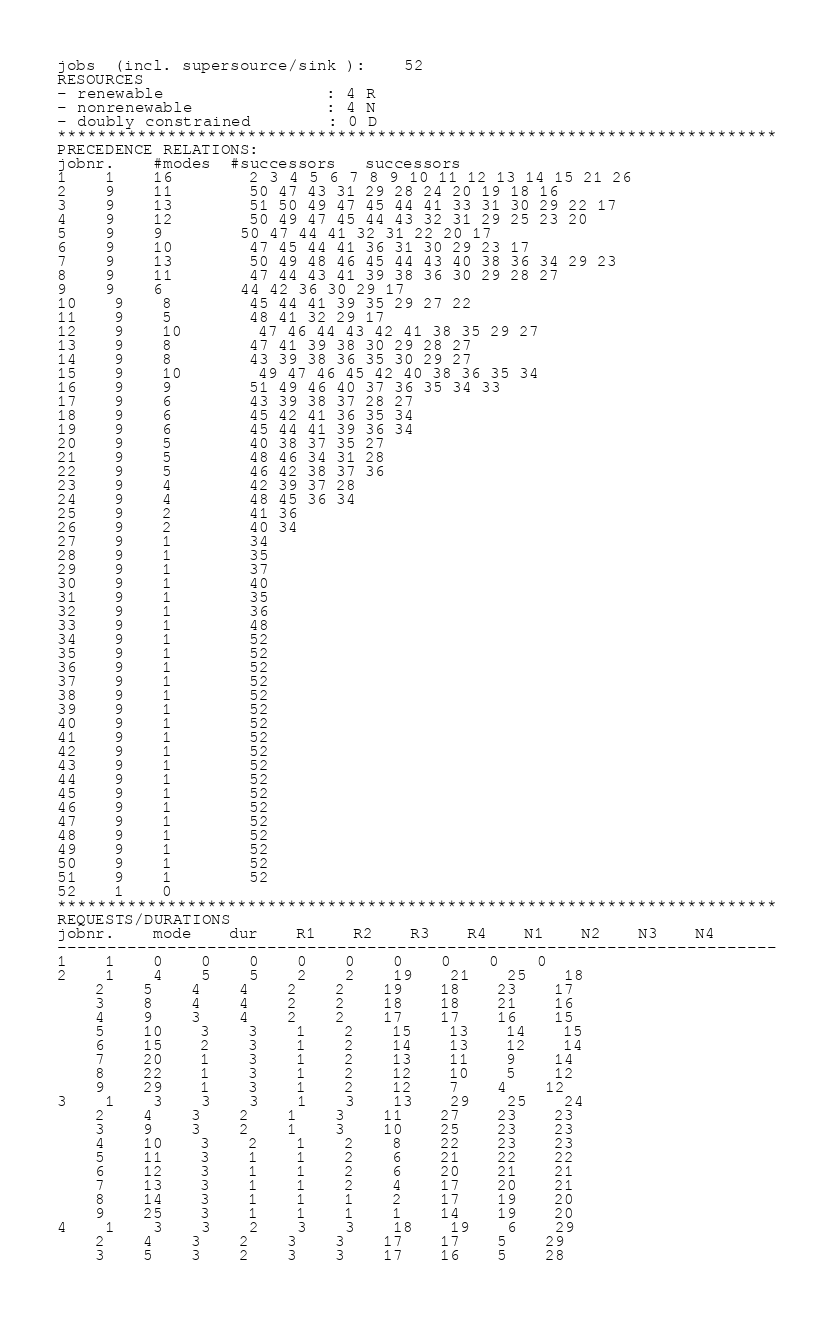Convert code to text. <code><loc_0><loc_0><loc_500><loc_500><_ObjectiveC_>jobs  (incl. supersource/sink ):	52
RESOURCES
- renewable                 : 4 R
- nonrenewable              : 4 N
- doubly constrained        : 0 D
************************************************************************
PRECEDENCE RELATIONS:
jobnr.    #modes  #successors   successors
1	1	16		2 3 4 5 6 7 8 9 10 11 12 13 14 15 21 26 
2	9	11		50 47 43 31 29 28 24 20 19 18 16 
3	9	13		51 50 49 47 45 44 41 33 31 30 29 22 17 
4	9	12		50 49 47 45 44 43 32 31 29 25 23 20 
5	9	9		50 47 44 41 32 31 22 20 17 
6	9	10		47 45 44 41 36 31 30 29 23 17 
7	9	13		50 49 48 46 45 44 43 40 38 36 34 29 23 
8	9	11		47 44 43 41 39 38 36 30 29 28 27 
9	9	6		44 42 36 30 29 17 
10	9	8		45 44 41 39 35 29 27 22 
11	9	5		48 41 32 29 17 
12	9	10		47 46 44 43 42 41 38 35 29 27 
13	9	8		47 41 39 38 30 29 28 27 
14	9	8		43 39 38 36 35 30 29 27 
15	9	10		49 47 46 45 42 40 38 36 35 34 
16	9	9		51 49 46 40 37 36 35 34 33 
17	9	6		43 39 38 37 28 27 
18	9	6		45 42 41 36 35 34 
19	9	6		45 44 41 39 36 34 
20	9	5		40 38 37 35 27 
21	9	5		48 46 34 31 28 
22	9	5		46 42 38 37 36 
23	9	4		42 39 37 28 
24	9	4		48 45 36 34 
25	9	2		41 36 
26	9	2		40 34 
27	9	1		34 
28	9	1		35 
29	9	1		37 
30	9	1		40 
31	9	1		35 
32	9	1		36 
33	9	1		48 
34	9	1		52 
35	9	1		52 
36	9	1		52 
37	9	1		52 
38	9	1		52 
39	9	1		52 
40	9	1		52 
41	9	1		52 
42	9	1		52 
43	9	1		52 
44	9	1		52 
45	9	1		52 
46	9	1		52 
47	9	1		52 
48	9	1		52 
49	9	1		52 
50	9	1		52 
51	9	1		52 
52	1	0		
************************************************************************
REQUESTS/DURATIONS
jobnr.	mode	dur	R1	R2	R3	R4	N1	N2	N3	N4	
------------------------------------------------------------------------
1	1	0	0	0	0	0	0	0	0	0	
2	1	4	5	5	2	2	19	21	25	18	
	2	5	4	4	2	2	19	18	23	17	
	3	8	4	4	2	2	18	18	21	16	
	4	9	3	4	2	2	17	17	16	15	
	5	10	3	3	1	2	15	13	14	15	
	6	15	2	3	1	2	14	13	12	14	
	7	20	1	3	1	2	13	11	9	14	
	8	22	1	3	1	2	12	10	5	12	
	9	29	1	3	1	2	12	7	4	12	
3	1	3	3	3	1	3	13	29	25	24	
	2	4	3	2	1	3	11	27	23	23	
	3	9	3	2	1	3	10	25	23	23	
	4	10	3	2	1	2	8	22	23	23	
	5	11	3	1	1	2	6	21	22	22	
	6	12	3	1	1	2	6	20	21	21	
	7	13	3	1	1	2	4	17	20	21	
	8	14	3	1	1	1	2	17	19	20	
	9	25	3	1	1	1	1	14	19	20	
4	1	3	3	2	3	3	18	19	6	29	
	2	4	3	2	3	3	17	17	5	29	
	3	5	3	2	3	3	17	16	5	28	</code> 